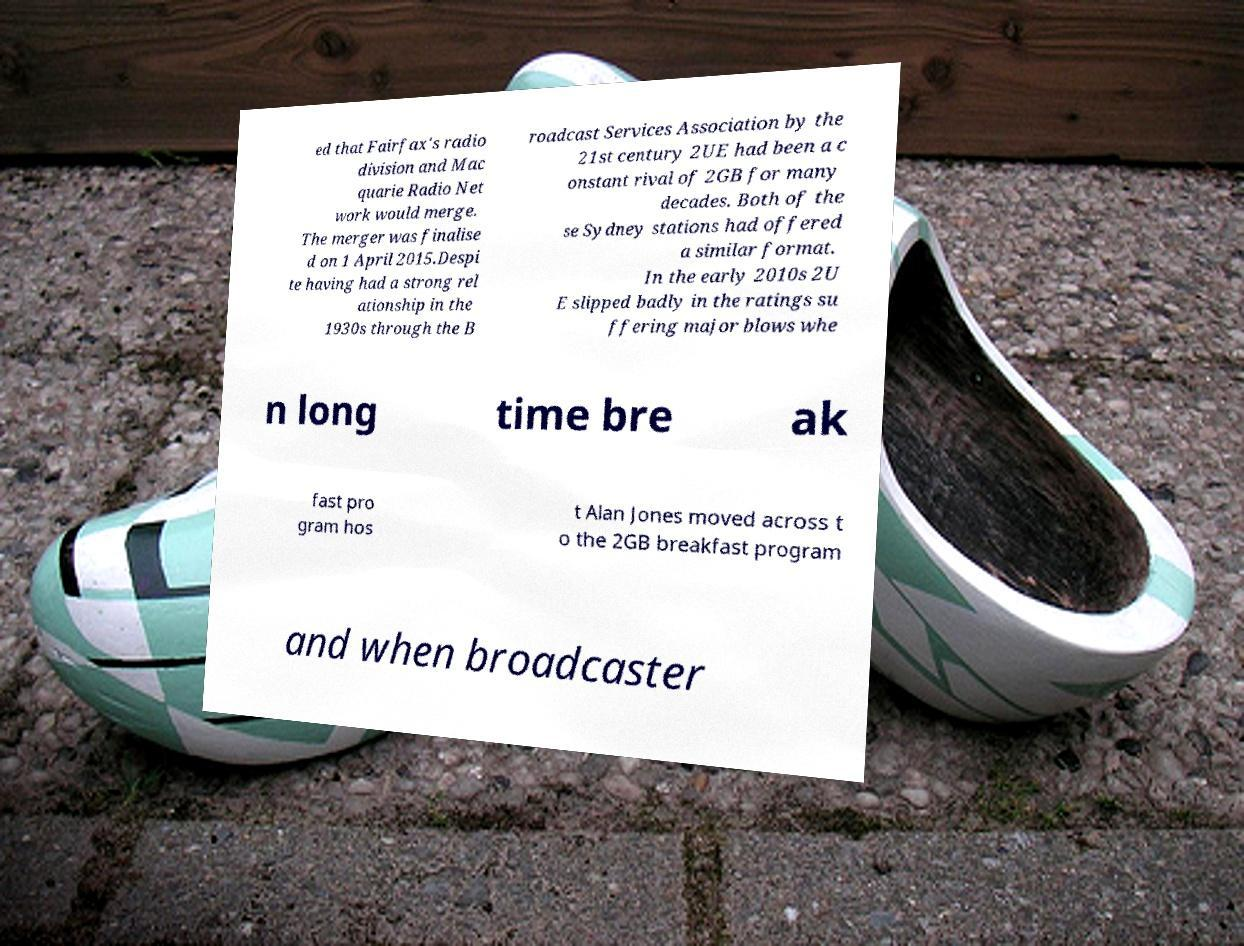Can you read and provide the text displayed in the image?This photo seems to have some interesting text. Can you extract and type it out for me? ed that Fairfax's radio division and Mac quarie Radio Net work would merge. The merger was finalise d on 1 April 2015.Despi te having had a strong rel ationship in the 1930s through the B roadcast Services Association by the 21st century 2UE had been a c onstant rival of 2GB for many decades. Both of the se Sydney stations had offered a similar format. In the early 2010s 2U E slipped badly in the ratings su ffering major blows whe n long time bre ak fast pro gram hos t Alan Jones moved across t o the 2GB breakfast program and when broadcaster 